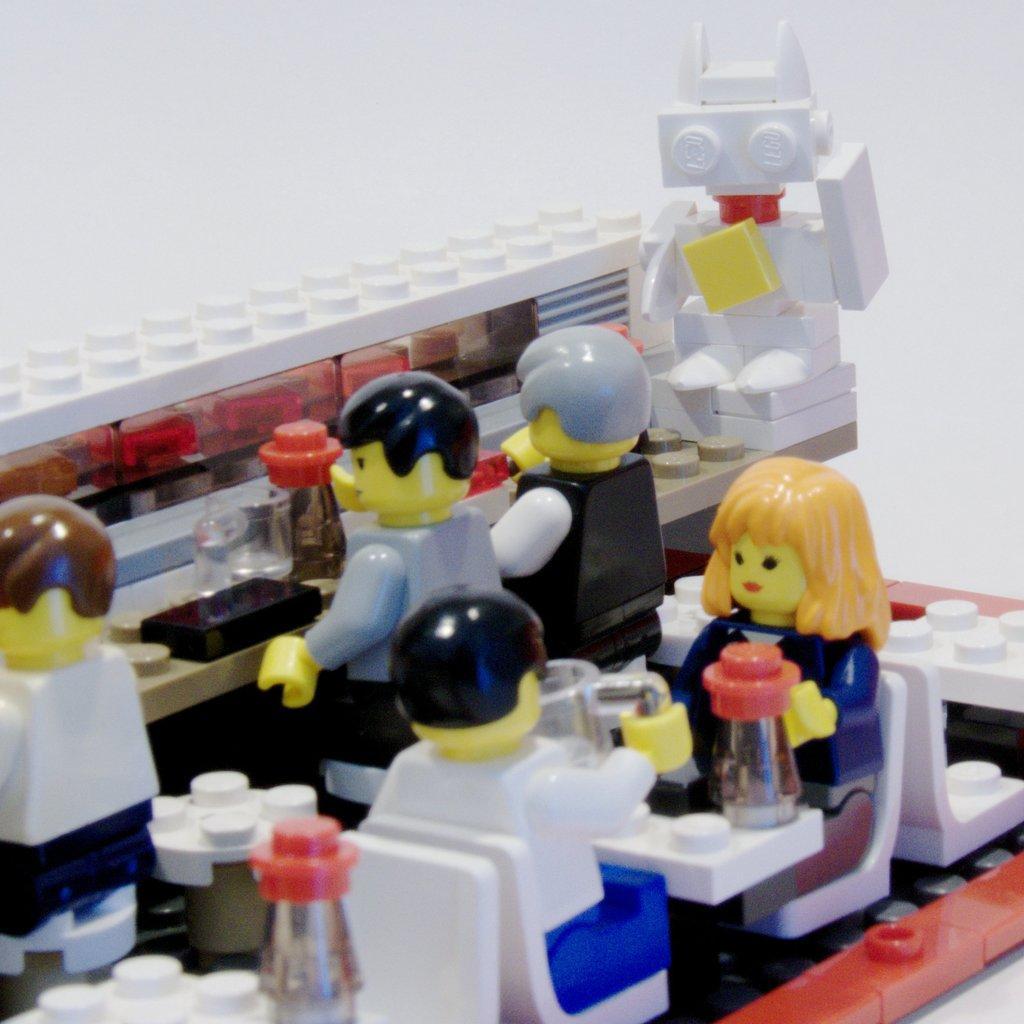Could you give a brief overview of what you see in this image? In this picture I can see the toys. 